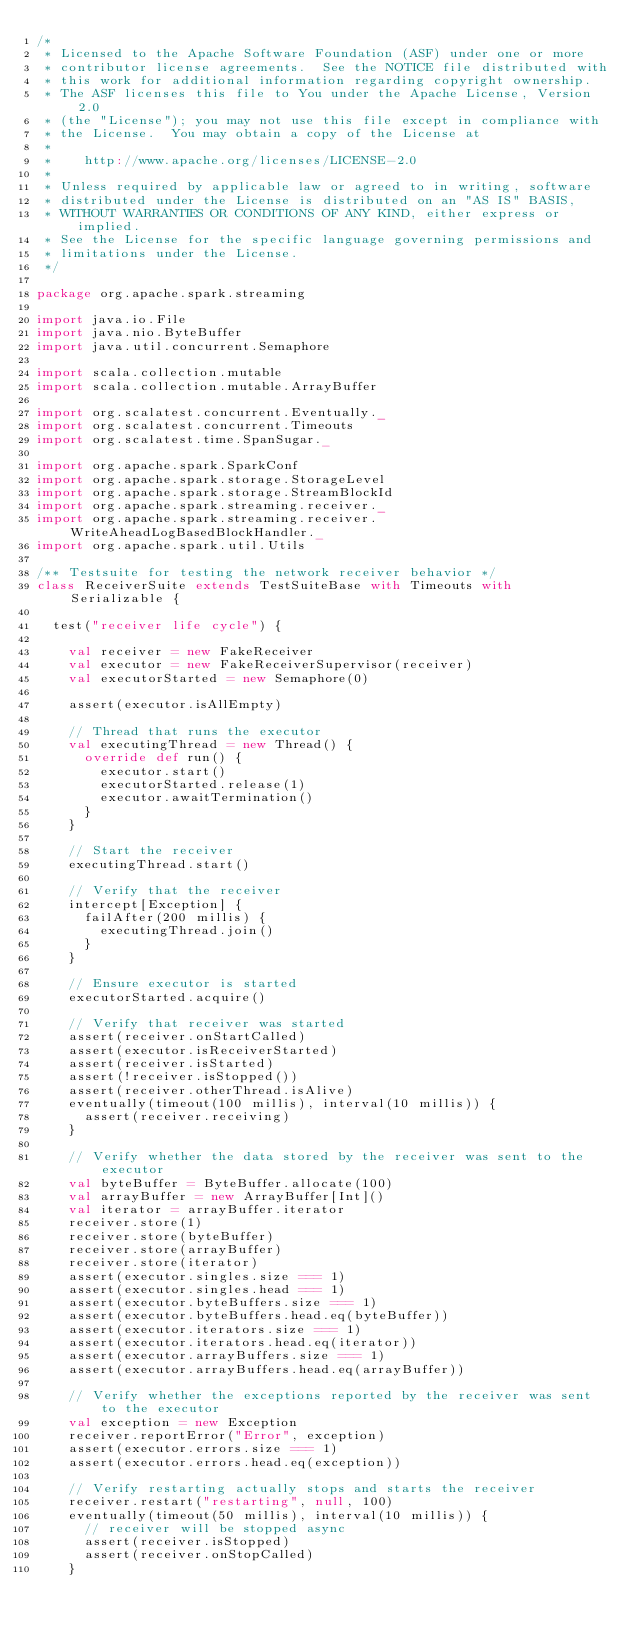Convert code to text. <code><loc_0><loc_0><loc_500><loc_500><_Scala_>/*
 * Licensed to the Apache Software Foundation (ASF) under one or more
 * contributor license agreements.  See the NOTICE file distributed with
 * this work for additional information regarding copyright ownership.
 * The ASF licenses this file to You under the Apache License, Version 2.0
 * (the "License"); you may not use this file except in compliance with
 * the License.  You may obtain a copy of the License at
 *
 *    http://www.apache.org/licenses/LICENSE-2.0
 *
 * Unless required by applicable law or agreed to in writing, software
 * distributed under the License is distributed on an "AS IS" BASIS,
 * WITHOUT WARRANTIES OR CONDITIONS OF ANY KIND, either express or implied.
 * See the License for the specific language governing permissions and
 * limitations under the License.
 */

package org.apache.spark.streaming

import java.io.File
import java.nio.ByteBuffer
import java.util.concurrent.Semaphore

import scala.collection.mutable
import scala.collection.mutable.ArrayBuffer

import org.scalatest.concurrent.Eventually._
import org.scalatest.concurrent.Timeouts
import org.scalatest.time.SpanSugar._

import org.apache.spark.SparkConf
import org.apache.spark.storage.StorageLevel
import org.apache.spark.storage.StreamBlockId
import org.apache.spark.streaming.receiver._
import org.apache.spark.streaming.receiver.WriteAheadLogBasedBlockHandler._
import org.apache.spark.util.Utils

/** Testsuite for testing the network receiver behavior */
class ReceiverSuite extends TestSuiteBase with Timeouts with Serializable {

  test("receiver life cycle") {

    val receiver = new FakeReceiver
    val executor = new FakeReceiverSupervisor(receiver)
    val executorStarted = new Semaphore(0)

    assert(executor.isAllEmpty)

    // Thread that runs the executor
    val executingThread = new Thread() {
      override def run() {
        executor.start()
        executorStarted.release(1)
        executor.awaitTermination()
      }
    }

    // Start the receiver
    executingThread.start()

    // Verify that the receiver
    intercept[Exception] {
      failAfter(200 millis) {
        executingThread.join()
      }
    }

    // Ensure executor is started
    executorStarted.acquire()

    // Verify that receiver was started
    assert(receiver.onStartCalled)
    assert(executor.isReceiverStarted)
    assert(receiver.isStarted)
    assert(!receiver.isStopped())
    assert(receiver.otherThread.isAlive)
    eventually(timeout(100 millis), interval(10 millis)) {
      assert(receiver.receiving)
    }

    // Verify whether the data stored by the receiver was sent to the executor
    val byteBuffer = ByteBuffer.allocate(100)
    val arrayBuffer = new ArrayBuffer[Int]()
    val iterator = arrayBuffer.iterator
    receiver.store(1)
    receiver.store(byteBuffer)
    receiver.store(arrayBuffer)
    receiver.store(iterator)
    assert(executor.singles.size === 1)
    assert(executor.singles.head === 1)
    assert(executor.byteBuffers.size === 1)
    assert(executor.byteBuffers.head.eq(byteBuffer))
    assert(executor.iterators.size === 1)
    assert(executor.iterators.head.eq(iterator))
    assert(executor.arrayBuffers.size === 1)
    assert(executor.arrayBuffers.head.eq(arrayBuffer))

    // Verify whether the exceptions reported by the receiver was sent to the executor
    val exception = new Exception
    receiver.reportError("Error", exception)
    assert(executor.errors.size === 1)
    assert(executor.errors.head.eq(exception))

    // Verify restarting actually stops and starts the receiver
    receiver.restart("restarting", null, 100)
    eventually(timeout(50 millis), interval(10 millis)) {
      // receiver will be stopped async
      assert(receiver.isStopped)
      assert(receiver.onStopCalled)
    }</code> 